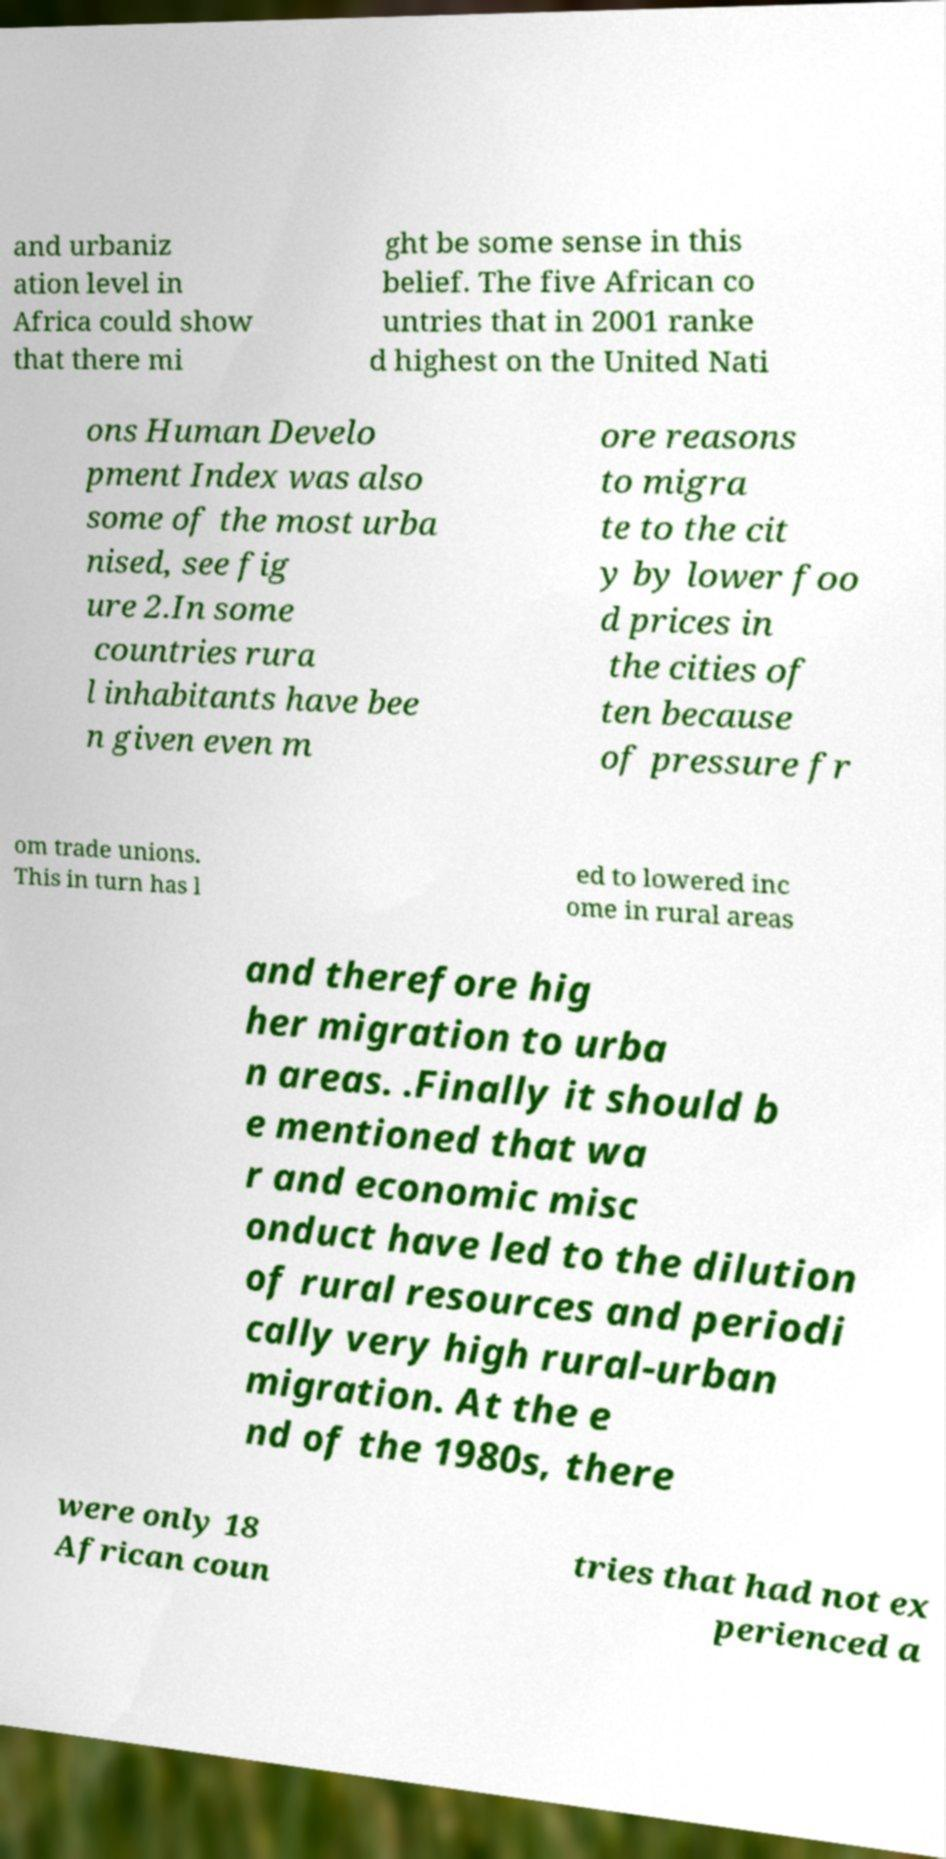For documentation purposes, I need the text within this image transcribed. Could you provide that? and urbaniz ation level in Africa could show that there mi ght be some sense in this belief. The five African co untries that in 2001 ranke d highest on the United Nati ons Human Develo pment Index was also some of the most urba nised, see fig ure 2.In some countries rura l inhabitants have bee n given even m ore reasons to migra te to the cit y by lower foo d prices in the cities of ten because of pressure fr om trade unions. This in turn has l ed to lowered inc ome in rural areas and therefore hig her migration to urba n areas. .Finally it should b e mentioned that wa r and economic misc onduct have led to the dilution of rural resources and periodi cally very high rural-urban migration. At the e nd of the 1980s, there were only 18 African coun tries that had not ex perienced a 